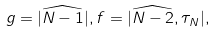<formula> <loc_0><loc_0><loc_500><loc_500>g = | \widehat { N - 1 } | , f = | \widehat { N - 2 } , \tau _ { N } | ,</formula> 